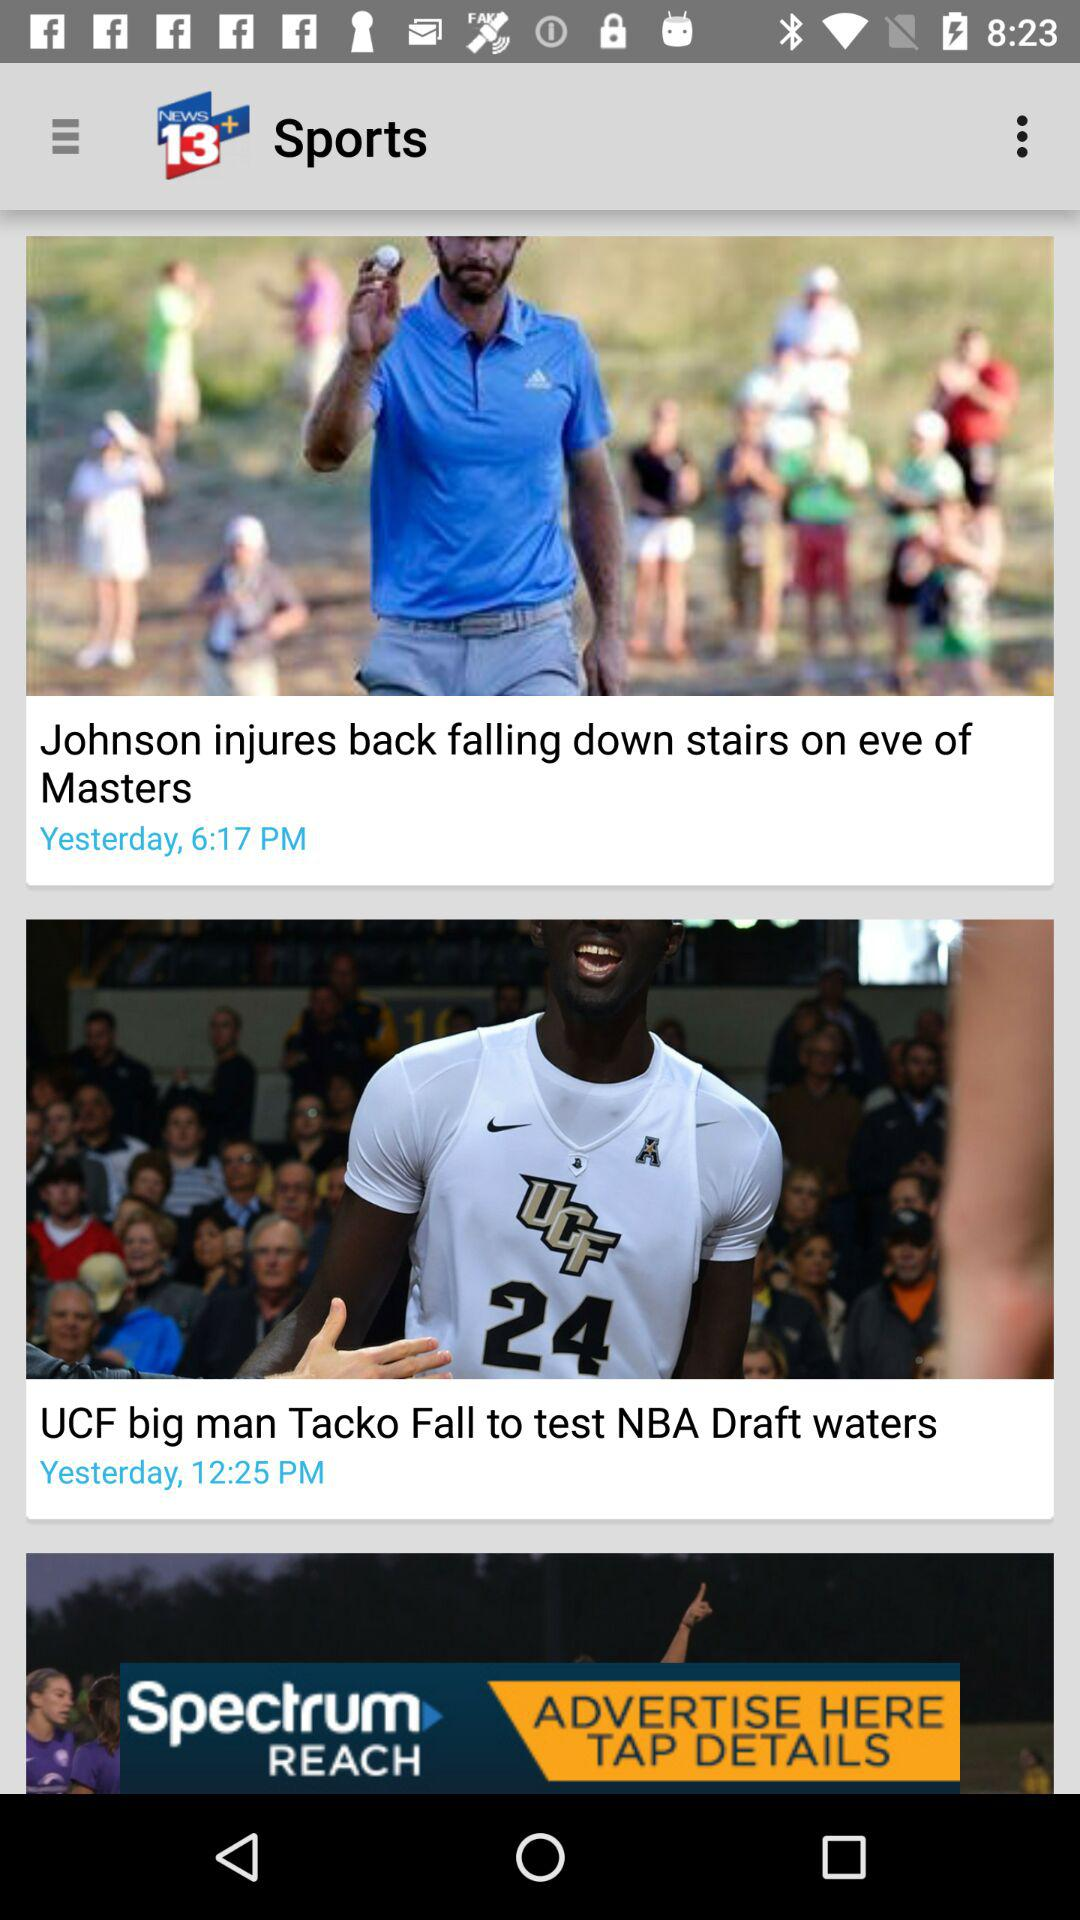What is the name of the application where the article is posted? The application is "News 13+" where the article is posted. 